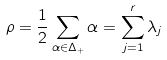Convert formula to latex. <formula><loc_0><loc_0><loc_500><loc_500>\rho = \frac { 1 } { 2 } \sum _ { \alpha \in \Delta _ { + } } \alpha = \sum _ { j = 1 } ^ { r } \lambda _ { j }</formula> 